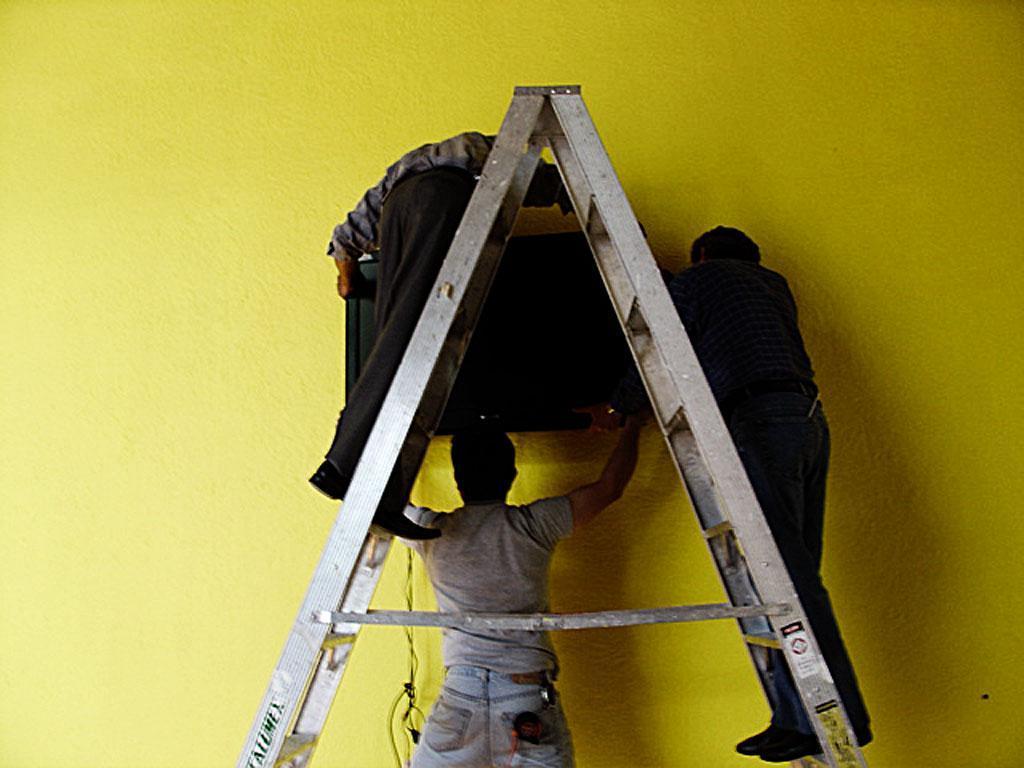Describe this image in one or two sentences. In this picture we can see a person standing and holding a television, there are two persons standing on the ladder, in the background we can see a wall. 